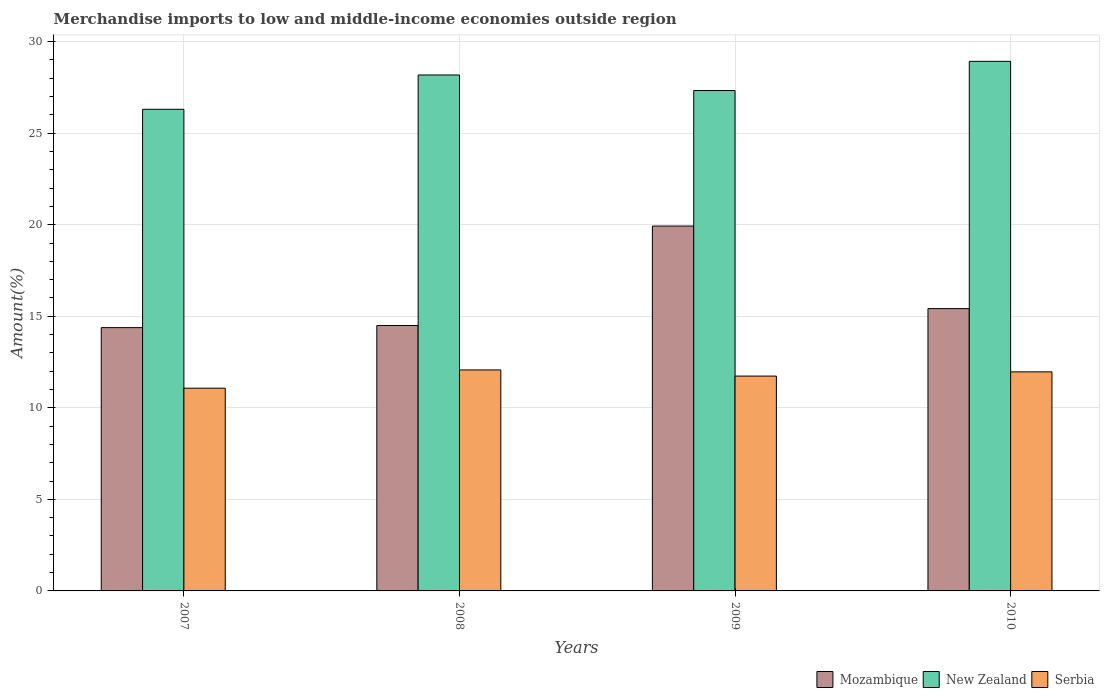How many groups of bars are there?
Your answer should be compact. 4. How many bars are there on the 1st tick from the left?
Keep it short and to the point. 3. How many bars are there on the 3rd tick from the right?
Keep it short and to the point. 3. In how many cases, is the number of bars for a given year not equal to the number of legend labels?
Provide a succinct answer. 0. What is the percentage of amount earned from merchandise imports in Mozambique in 2009?
Give a very brief answer. 19.93. Across all years, what is the maximum percentage of amount earned from merchandise imports in New Zealand?
Make the answer very short. 28.92. Across all years, what is the minimum percentage of amount earned from merchandise imports in New Zealand?
Your answer should be very brief. 26.31. In which year was the percentage of amount earned from merchandise imports in Serbia maximum?
Offer a terse response. 2008. What is the total percentage of amount earned from merchandise imports in New Zealand in the graph?
Provide a short and direct response. 110.74. What is the difference between the percentage of amount earned from merchandise imports in Mozambique in 2008 and that in 2010?
Offer a terse response. -0.92. What is the difference between the percentage of amount earned from merchandise imports in Serbia in 2007 and the percentage of amount earned from merchandise imports in Mozambique in 2009?
Provide a succinct answer. -8.86. What is the average percentage of amount earned from merchandise imports in New Zealand per year?
Provide a short and direct response. 27.69. In the year 2008, what is the difference between the percentage of amount earned from merchandise imports in Mozambique and percentage of amount earned from merchandise imports in New Zealand?
Make the answer very short. -13.68. In how many years, is the percentage of amount earned from merchandise imports in New Zealand greater than 29 %?
Offer a very short reply. 0. What is the ratio of the percentage of amount earned from merchandise imports in Serbia in 2007 to that in 2010?
Provide a short and direct response. 0.93. Is the percentage of amount earned from merchandise imports in New Zealand in 2009 less than that in 2010?
Give a very brief answer. Yes. What is the difference between the highest and the second highest percentage of amount earned from merchandise imports in New Zealand?
Offer a very short reply. 0.74. What is the difference between the highest and the lowest percentage of amount earned from merchandise imports in Mozambique?
Offer a terse response. 5.55. Is the sum of the percentage of amount earned from merchandise imports in New Zealand in 2008 and 2009 greater than the maximum percentage of amount earned from merchandise imports in Serbia across all years?
Your answer should be very brief. Yes. What does the 2nd bar from the left in 2010 represents?
Your response must be concise. New Zealand. What does the 2nd bar from the right in 2010 represents?
Make the answer very short. New Zealand. Is it the case that in every year, the sum of the percentage of amount earned from merchandise imports in New Zealand and percentage of amount earned from merchandise imports in Serbia is greater than the percentage of amount earned from merchandise imports in Mozambique?
Your response must be concise. Yes. How many bars are there?
Give a very brief answer. 12. Are all the bars in the graph horizontal?
Offer a terse response. No. Are the values on the major ticks of Y-axis written in scientific E-notation?
Make the answer very short. No. Does the graph contain grids?
Offer a terse response. Yes. What is the title of the graph?
Make the answer very short. Merchandise imports to low and middle-income economies outside region. Does "Cuba" appear as one of the legend labels in the graph?
Provide a short and direct response. No. What is the label or title of the Y-axis?
Your answer should be compact. Amount(%). What is the Amount(%) in Mozambique in 2007?
Your answer should be compact. 14.38. What is the Amount(%) of New Zealand in 2007?
Keep it short and to the point. 26.31. What is the Amount(%) of Serbia in 2007?
Provide a short and direct response. 11.07. What is the Amount(%) in Mozambique in 2008?
Offer a very short reply. 14.5. What is the Amount(%) in New Zealand in 2008?
Make the answer very short. 28.18. What is the Amount(%) of Serbia in 2008?
Provide a short and direct response. 12.07. What is the Amount(%) in Mozambique in 2009?
Your response must be concise. 19.93. What is the Amount(%) in New Zealand in 2009?
Your response must be concise. 27.33. What is the Amount(%) in Serbia in 2009?
Your response must be concise. 11.73. What is the Amount(%) in Mozambique in 2010?
Your answer should be compact. 15.42. What is the Amount(%) in New Zealand in 2010?
Your answer should be very brief. 28.92. What is the Amount(%) in Serbia in 2010?
Offer a very short reply. 11.97. Across all years, what is the maximum Amount(%) of Mozambique?
Give a very brief answer. 19.93. Across all years, what is the maximum Amount(%) in New Zealand?
Keep it short and to the point. 28.92. Across all years, what is the maximum Amount(%) in Serbia?
Provide a succinct answer. 12.07. Across all years, what is the minimum Amount(%) in Mozambique?
Your answer should be compact. 14.38. Across all years, what is the minimum Amount(%) of New Zealand?
Ensure brevity in your answer.  26.31. Across all years, what is the minimum Amount(%) in Serbia?
Your answer should be very brief. 11.07. What is the total Amount(%) of Mozambique in the graph?
Provide a succinct answer. 64.22. What is the total Amount(%) of New Zealand in the graph?
Give a very brief answer. 110.74. What is the total Amount(%) in Serbia in the graph?
Ensure brevity in your answer.  46.84. What is the difference between the Amount(%) of Mozambique in 2007 and that in 2008?
Ensure brevity in your answer.  -0.12. What is the difference between the Amount(%) in New Zealand in 2007 and that in 2008?
Provide a succinct answer. -1.87. What is the difference between the Amount(%) of Serbia in 2007 and that in 2008?
Offer a terse response. -1. What is the difference between the Amount(%) in Mozambique in 2007 and that in 2009?
Offer a terse response. -5.55. What is the difference between the Amount(%) in New Zealand in 2007 and that in 2009?
Provide a short and direct response. -1.02. What is the difference between the Amount(%) of Serbia in 2007 and that in 2009?
Make the answer very short. -0.66. What is the difference between the Amount(%) of Mozambique in 2007 and that in 2010?
Offer a very short reply. -1.04. What is the difference between the Amount(%) of New Zealand in 2007 and that in 2010?
Provide a succinct answer. -2.62. What is the difference between the Amount(%) of Serbia in 2007 and that in 2010?
Your answer should be very brief. -0.89. What is the difference between the Amount(%) of Mozambique in 2008 and that in 2009?
Ensure brevity in your answer.  -5.43. What is the difference between the Amount(%) in New Zealand in 2008 and that in 2009?
Your response must be concise. 0.85. What is the difference between the Amount(%) in Serbia in 2008 and that in 2009?
Give a very brief answer. 0.34. What is the difference between the Amount(%) of Mozambique in 2008 and that in 2010?
Make the answer very short. -0.92. What is the difference between the Amount(%) of New Zealand in 2008 and that in 2010?
Offer a very short reply. -0.74. What is the difference between the Amount(%) of Serbia in 2008 and that in 2010?
Offer a very short reply. 0.11. What is the difference between the Amount(%) in Mozambique in 2009 and that in 2010?
Your answer should be very brief. 4.51. What is the difference between the Amount(%) of New Zealand in 2009 and that in 2010?
Your response must be concise. -1.59. What is the difference between the Amount(%) of Serbia in 2009 and that in 2010?
Ensure brevity in your answer.  -0.23. What is the difference between the Amount(%) of Mozambique in 2007 and the Amount(%) of New Zealand in 2008?
Offer a very short reply. -13.8. What is the difference between the Amount(%) in Mozambique in 2007 and the Amount(%) in Serbia in 2008?
Make the answer very short. 2.31. What is the difference between the Amount(%) in New Zealand in 2007 and the Amount(%) in Serbia in 2008?
Provide a succinct answer. 14.24. What is the difference between the Amount(%) of Mozambique in 2007 and the Amount(%) of New Zealand in 2009?
Offer a terse response. -12.95. What is the difference between the Amount(%) in Mozambique in 2007 and the Amount(%) in Serbia in 2009?
Make the answer very short. 2.65. What is the difference between the Amount(%) in New Zealand in 2007 and the Amount(%) in Serbia in 2009?
Offer a terse response. 14.57. What is the difference between the Amount(%) in Mozambique in 2007 and the Amount(%) in New Zealand in 2010?
Offer a very short reply. -14.54. What is the difference between the Amount(%) of Mozambique in 2007 and the Amount(%) of Serbia in 2010?
Your answer should be compact. 2.41. What is the difference between the Amount(%) of New Zealand in 2007 and the Amount(%) of Serbia in 2010?
Provide a short and direct response. 14.34. What is the difference between the Amount(%) of Mozambique in 2008 and the Amount(%) of New Zealand in 2009?
Your response must be concise. -12.83. What is the difference between the Amount(%) in Mozambique in 2008 and the Amount(%) in Serbia in 2009?
Your answer should be very brief. 2.76. What is the difference between the Amount(%) in New Zealand in 2008 and the Amount(%) in Serbia in 2009?
Make the answer very short. 16.45. What is the difference between the Amount(%) in Mozambique in 2008 and the Amount(%) in New Zealand in 2010?
Your answer should be very brief. -14.43. What is the difference between the Amount(%) in Mozambique in 2008 and the Amount(%) in Serbia in 2010?
Your response must be concise. 2.53. What is the difference between the Amount(%) of New Zealand in 2008 and the Amount(%) of Serbia in 2010?
Offer a very short reply. 16.21. What is the difference between the Amount(%) in Mozambique in 2009 and the Amount(%) in New Zealand in 2010?
Provide a short and direct response. -9. What is the difference between the Amount(%) in Mozambique in 2009 and the Amount(%) in Serbia in 2010?
Give a very brief answer. 7.96. What is the difference between the Amount(%) of New Zealand in 2009 and the Amount(%) of Serbia in 2010?
Offer a very short reply. 15.37. What is the average Amount(%) in Mozambique per year?
Make the answer very short. 16.06. What is the average Amount(%) of New Zealand per year?
Offer a very short reply. 27.69. What is the average Amount(%) in Serbia per year?
Give a very brief answer. 11.71. In the year 2007, what is the difference between the Amount(%) in Mozambique and Amount(%) in New Zealand?
Make the answer very short. -11.93. In the year 2007, what is the difference between the Amount(%) of Mozambique and Amount(%) of Serbia?
Offer a very short reply. 3.31. In the year 2007, what is the difference between the Amount(%) of New Zealand and Amount(%) of Serbia?
Make the answer very short. 15.23. In the year 2008, what is the difference between the Amount(%) of Mozambique and Amount(%) of New Zealand?
Keep it short and to the point. -13.68. In the year 2008, what is the difference between the Amount(%) in Mozambique and Amount(%) in Serbia?
Your response must be concise. 2.43. In the year 2008, what is the difference between the Amount(%) of New Zealand and Amount(%) of Serbia?
Make the answer very short. 16.11. In the year 2009, what is the difference between the Amount(%) in Mozambique and Amount(%) in New Zealand?
Provide a succinct answer. -7.4. In the year 2009, what is the difference between the Amount(%) in Mozambique and Amount(%) in Serbia?
Make the answer very short. 8.19. In the year 2009, what is the difference between the Amount(%) in New Zealand and Amount(%) in Serbia?
Provide a succinct answer. 15.6. In the year 2010, what is the difference between the Amount(%) in Mozambique and Amount(%) in New Zealand?
Your response must be concise. -13.5. In the year 2010, what is the difference between the Amount(%) in Mozambique and Amount(%) in Serbia?
Give a very brief answer. 3.45. In the year 2010, what is the difference between the Amount(%) in New Zealand and Amount(%) in Serbia?
Provide a succinct answer. 16.96. What is the ratio of the Amount(%) of Mozambique in 2007 to that in 2008?
Your answer should be very brief. 0.99. What is the ratio of the Amount(%) of New Zealand in 2007 to that in 2008?
Keep it short and to the point. 0.93. What is the ratio of the Amount(%) of Serbia in 2007 to that in 2008?
Give a very brief answer. 0.92. What is the ratio of the Amount(%) of Mozambique in 2007 to that in 2009?
Your answer should be compact. 0.72. What is the ratio of the Amount(%) of New Zealand in 2007 to that in 2009?
Your response must be concise. 0.96. What is the ratio of the Amount(%) in Serbia in 2007 to that in 2009?
Provide a short and direct response. 0.94. What is the ratio of the Amount(%) in Mozambique in 2007 to that in 2010?
Make the answer very short. 0.93. What is the ratio of the Amount(%) in New Zealand in 2007 to that in 2010?
Provide a succinct answer. 0.91. What is the ratio of the Amount(%) in Serbia in 2007 to that in 2010?
Keep it short and to the point. 0.93. What is the ratio of the Amount(%) in Mozambique in 2008 to that in 2009?
Give a very brief answer. 0.73. What is the ratio of the Amount(%) in New Zealand in 2008 to that in 2009?
Offer a terse response. 1.03. What is the ratio of the Amount(%) of Serbia in 2008 to that in 2009?
Keep it short and to the point. 1.03. What is the ratio of the Amount(%) in Mozambique in 2008 to that in 2010?
Offer a very short reply. 0.94. What is the ratio of the Amount(%) in New Zealand in 2008 to that in 2010?
Provide a short and direct response. 0.97. What is the ratio of the Amount(%) in Serbia in 2008 to that in 2010?
Your answer should be very brief. 1.01. What is the ratio of the Amount(%) in Mozambique in 2009 to that in 2010?
Provide a succinct answer. 1.29. What is the ratio of the Amount(%) of New Zealand in 2009 to that in 2010?
Provide a short and direct response. 0.94. What is the ratio of the Amount(%) in Serbia in 2009 to that in 2010?
Your answer should be very brief. 0.98. What is the difference between the highest and the second highest Amount(%) in Mozambique?
Keep it short and to the point. 4.51. What is the difference between the highest and the second highest Amount(%) of New Zealand?
Your response must be concise. 0.74. What is the difference between the highest and the second highest Amount(%) in Serbia?
Offer a terse response. 0.11. What is the difference between the highest and the lowest Amount(%) of Mozambique?
Offer a terse response. 5.55. What is the difference between the highest and the lowest Amount(%) in New Zealand?
Provide a succinct answer. 2.62. 